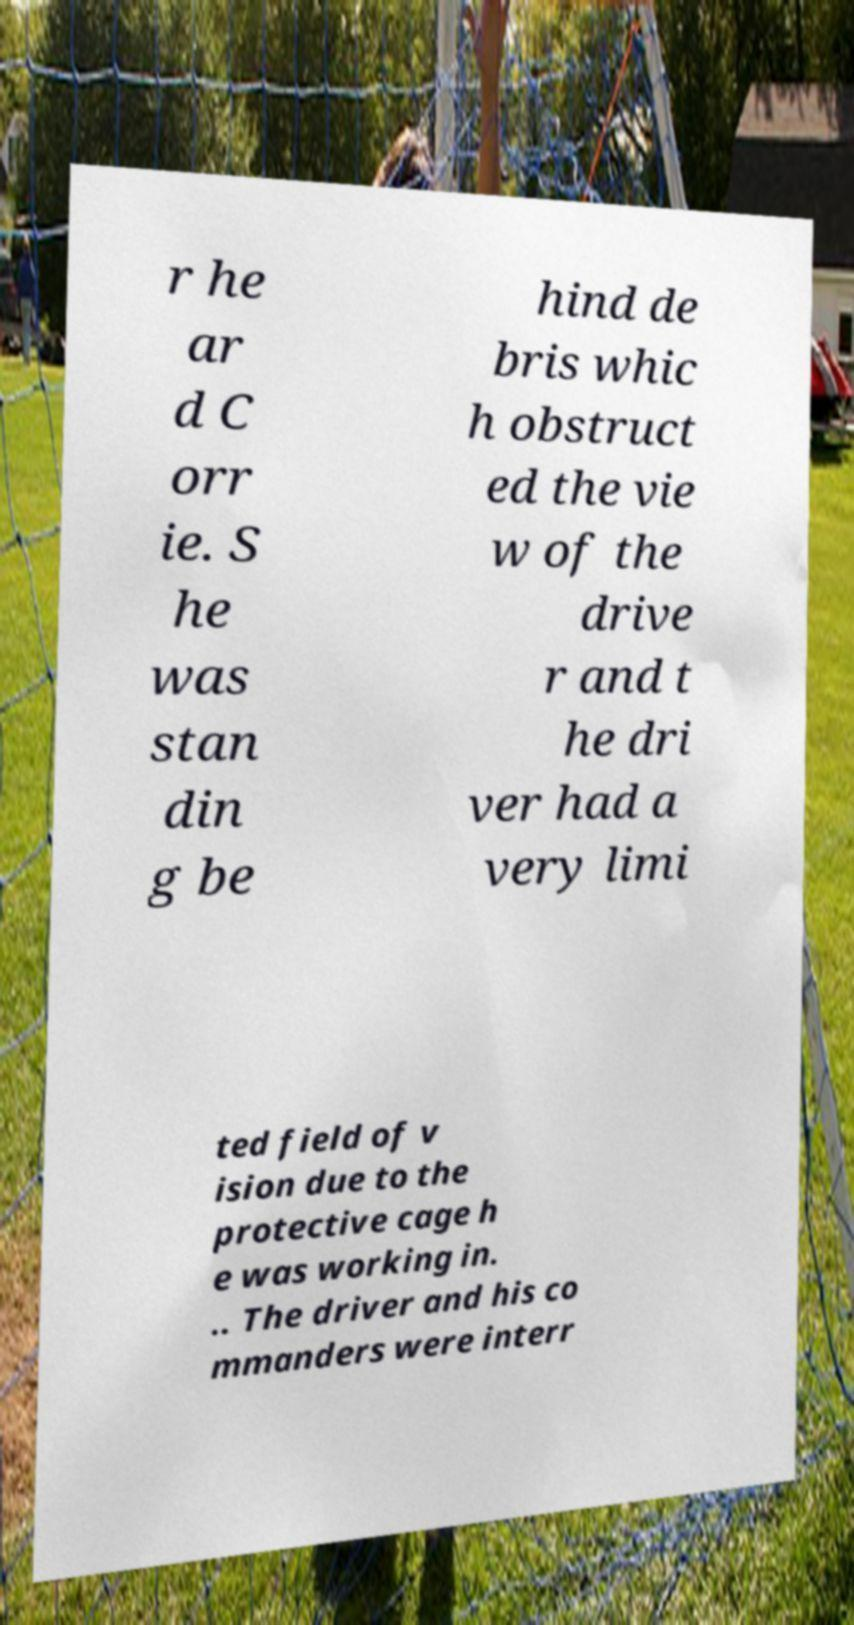Could you assist in decoding the text presented in this image and type it out clearly? r he ar d C orr ie. S he was stan din g be hind de bris whic h obstruct ed the vie w of the drive r and t he dri ver had a very limi ted field of v ision due to the protective cage h e was working in. .. The driver and his co mmanders were interr 